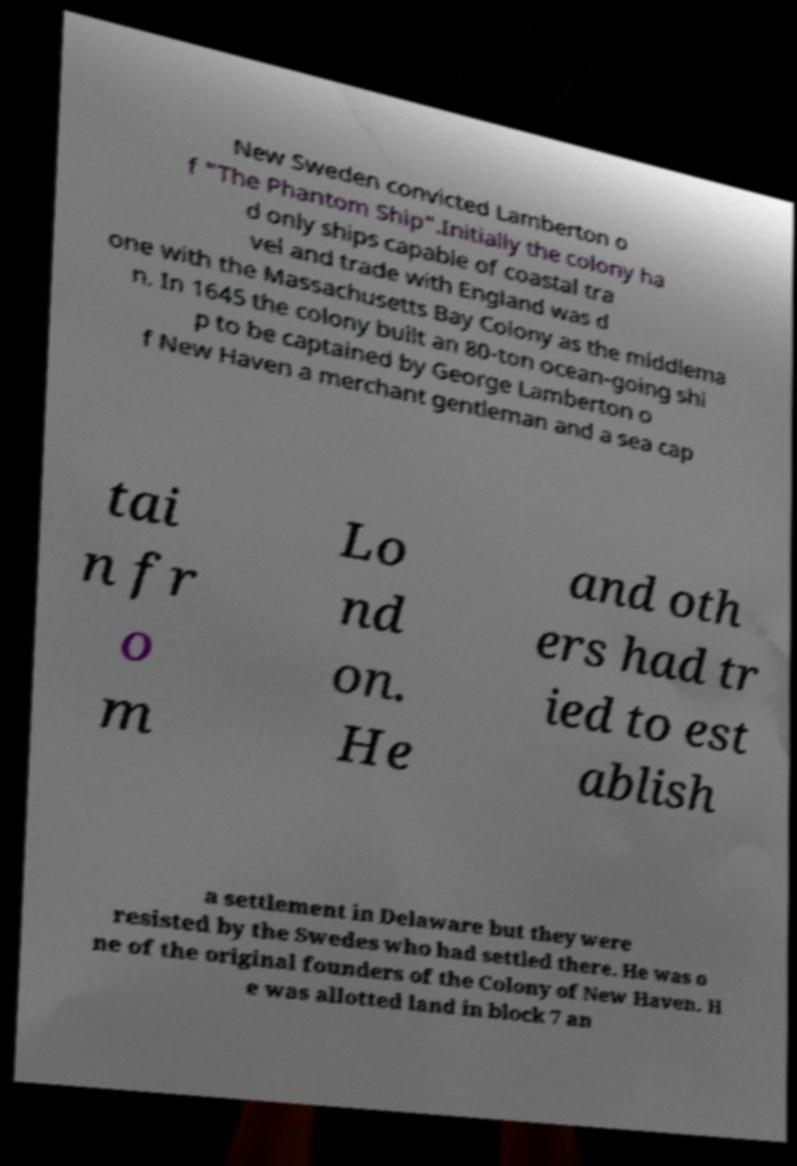Could you extract and type out the text from this image? New Sweden convicted Lamberton o f "The Phantom Ship".Initially the colony ha d only ships capable of coastal tra vel and trade with England was d one with the Massachusetts Bay Colony as the middlema n. In 1645 the colony built an 80-ton ocean-going shi p to be captained by George Lamberton o f New Haven a merchant gentleman and a sea cap tai n fr o m Lo nd on. He and oth ers had tr ied to est ablish a settlement in Delaware but they were resisted by the Swedes who had settled there. He was o ne of the original founders of the Colony of New Haven. H e was allotted land in block 7 an 